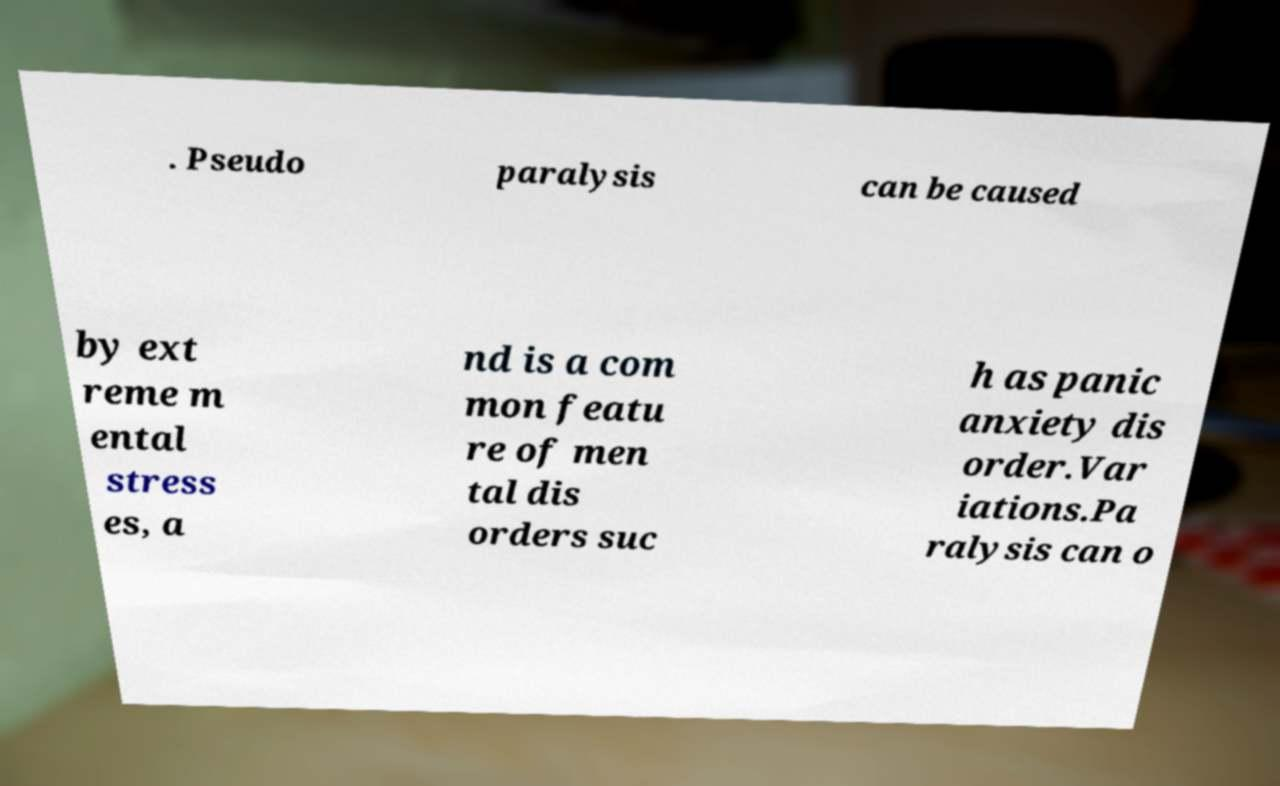I need the written content from this picture converted into text. Can you do that? . Pseudo paralysis can be caused by ext reme m ental stress es, a nd is a com mon featu re of men tal dis orders suc h as panic anxiety dis order.Var iations.Pa ralysis can o 